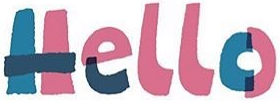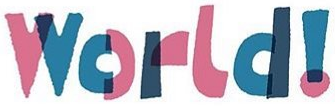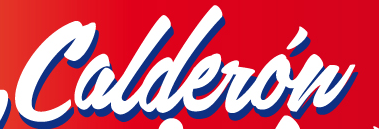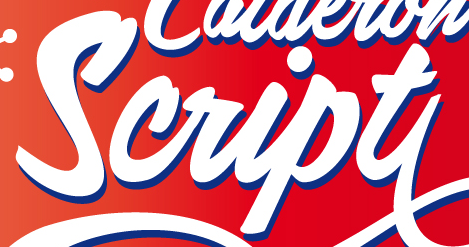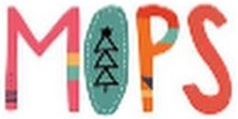Transcribe the words shown in these images in order, separated by a semicolon. Hello; World!; Calderów; Script; MOPS 